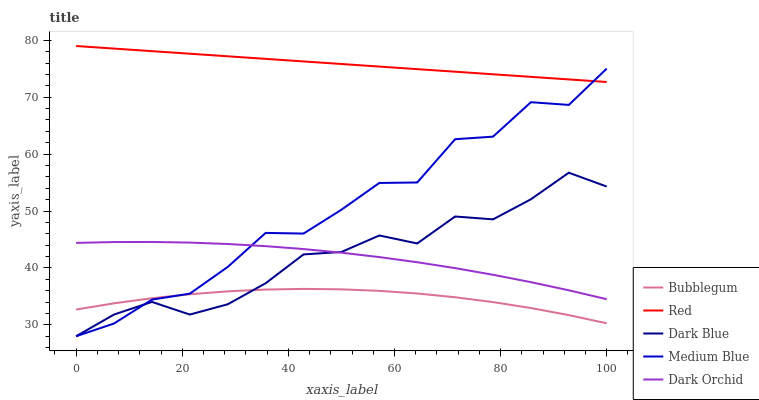Does Bubblegum have the minimum area under the curve?
Answer yes or no. Yes. Does Red have the maximum area under the curve?
Answer yes or no. Yes. Does Dark Blue have the minimum area under the curve?
Answer yes or no. No. Does Dark Blue have the maximum area under the curve?
Answer yes or no. No. Is Red the smoothest?
Answer yes or no. Yes. Is Medium Blue the roughest?
Answer yes or no. Yes. Is Dark Blue the smoothest?
Answer yes or no. No. Is Dark Blue the roughest?
Answer yes or no. No. Does Dark Blue have the lowest value?
Answer yes or no. Yes. Does Red have the lowest value?
Answer yes or no. No. Does Red have the highest value?
Answer yes or no. Yes. Does Dark Blue have the highest value?
Answer yes or no. No. Is Dark Orchid less than Red?
Answer yes or no. Yes. Is Red greater than Bubblegum?
Answer yes or no. Yes. Does Medium Blue intersect Dark Blue?
Answer yes or no. Yes. Is Medium Blue less than Dark Blue?
Answer yes or no. No. Is Medium Blue greater than Dark Blue?
Answer yes or no. No. Does Dark Orchid intersect Red?
Answer yes or no. No. 